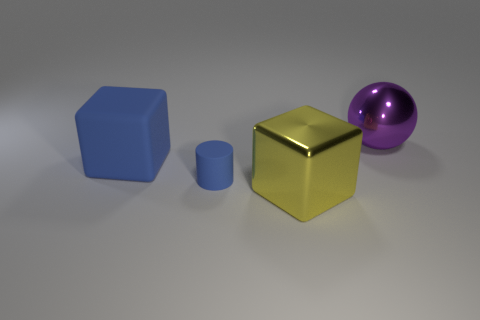Can you describe the lighting in this scene? The lighting in the scene seems to be coming from an undefined source above the objects, casting soft shadows beneath them. This diffused light indicates a general illumination without a strong directional light like the sun. 